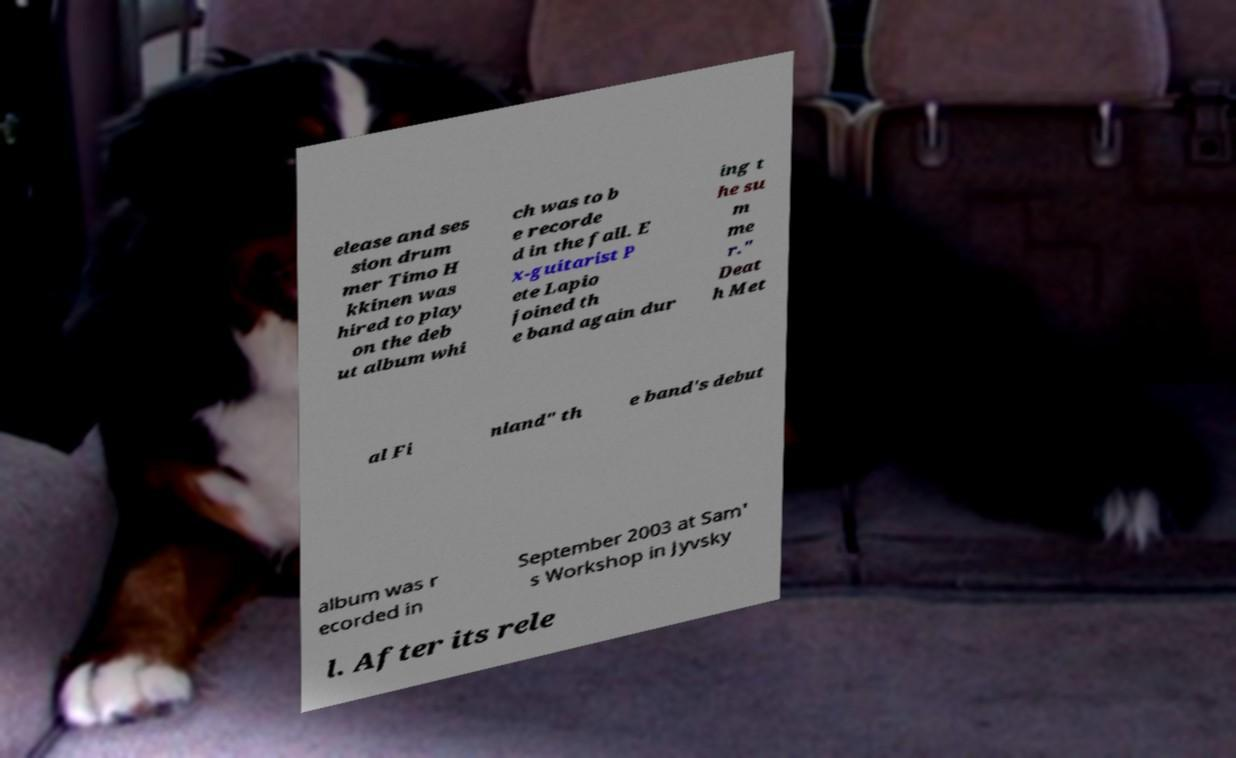Could you extract and type out the text from this image? elease and ses sion drum mer Timo H kkinen was hired to play on the deb ut album whi ch was to b e recorde d in the fall. E x-guitarist P ete Lapio joined th e band again dur ing t he su m me r." Deat h Met al Fi nland" th e band's debut album was r ecorded in September 2003 at Sam' s Workshop in Jyvsky l. After its rele 